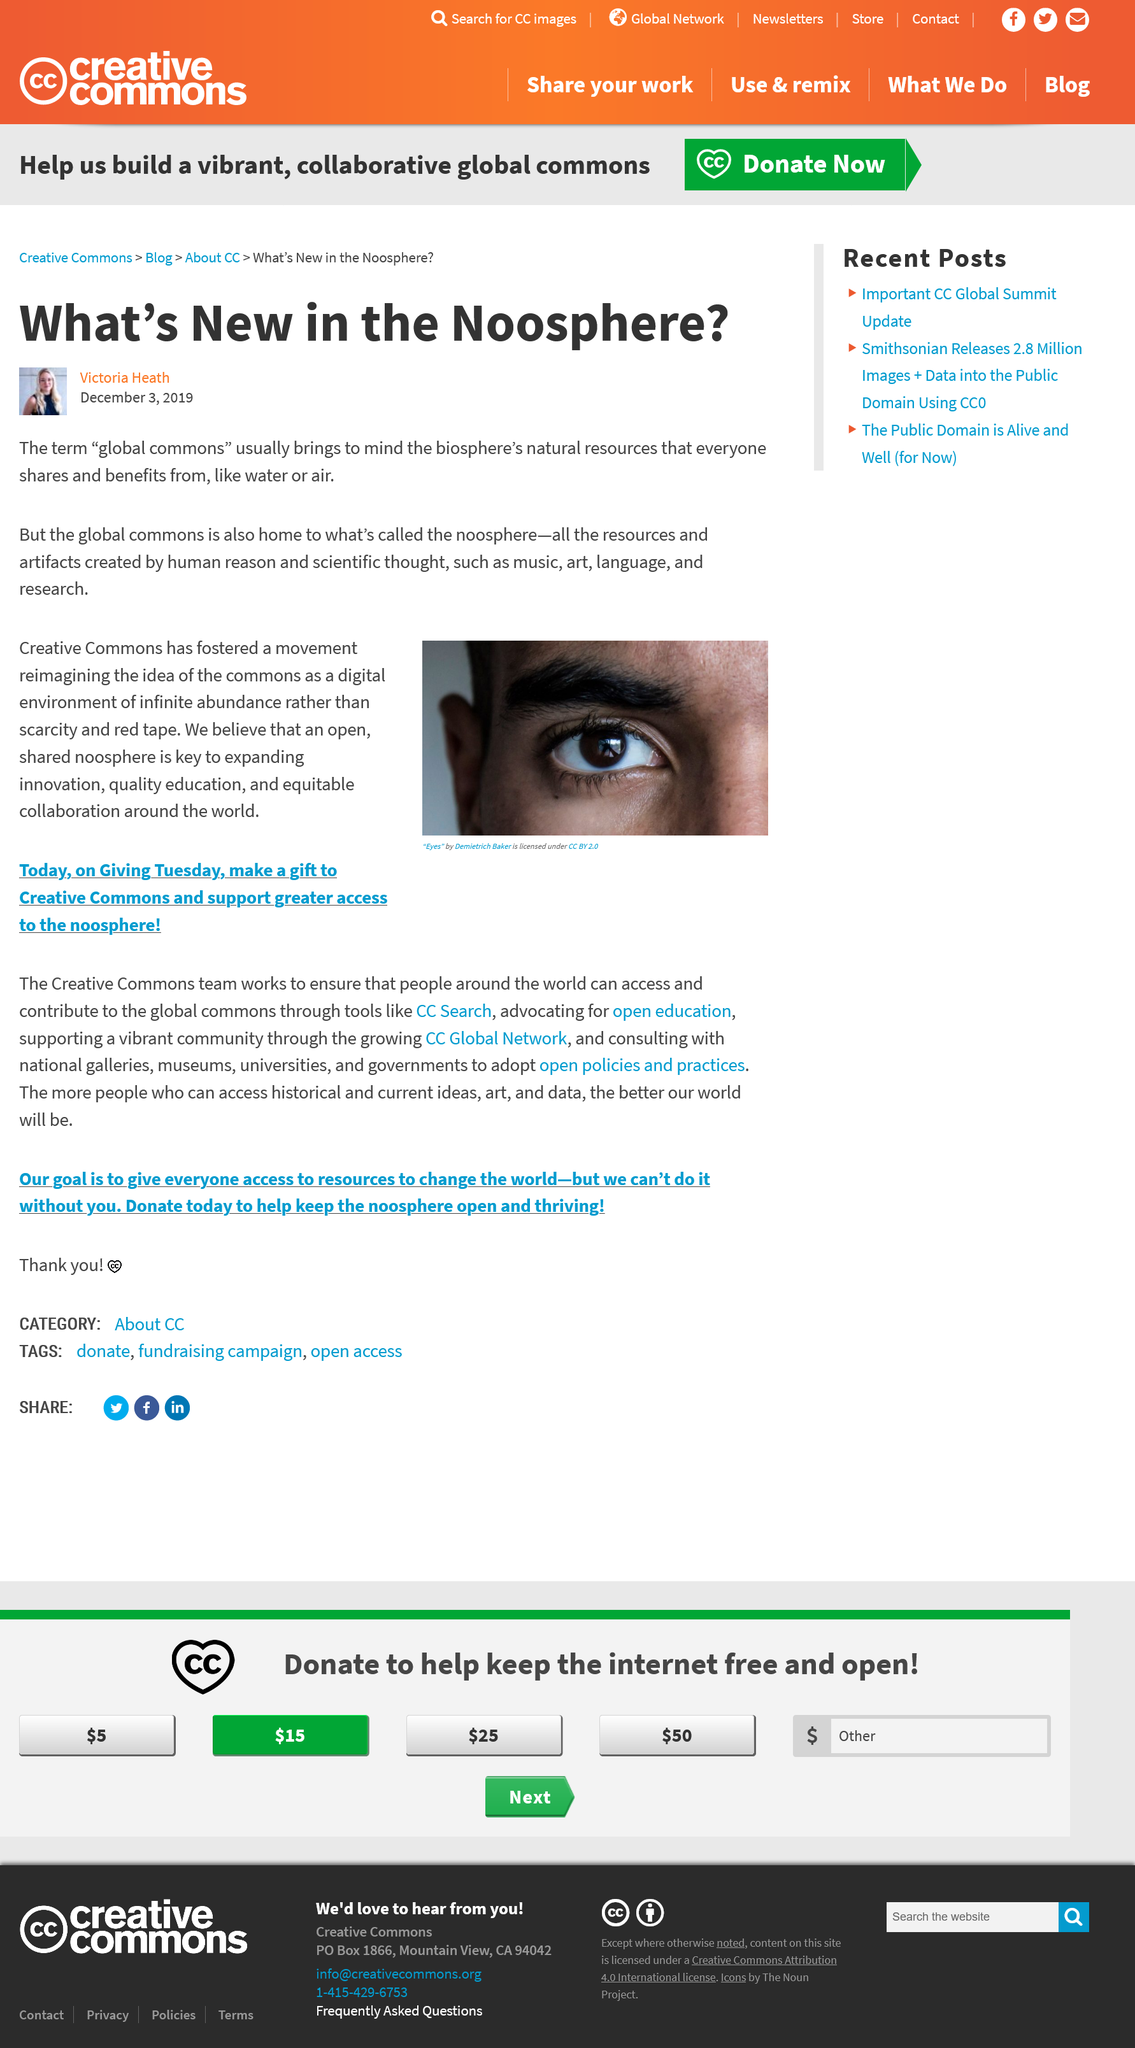Mention a couple of crucial points in this snapshot. The global commons includes not only natural resources, but also the noosphere, which refers to the realm of human intellect and knowledge, and is considered a vital part of the global commons. Water and air are two of the natural resources that are included in the biosphere. The noosphere is comprised of music, art, language, and research. 